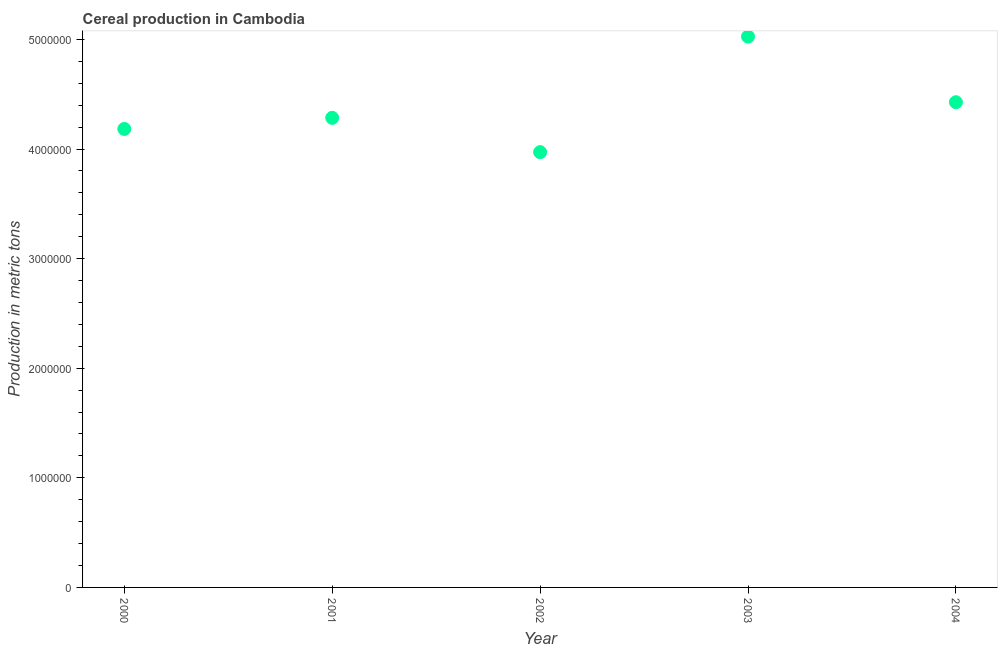What is the cereal production in 2001?
Keep it short and to the point. 4.28e+06. Across all years, what is the maximum cereal production?
Offer a terse response. 5.03e+06. Across all years, what is the minimum cereal production?
Keep it short and to the point. 3.97e+06. In which year was the cereal production maximum?
Offer a terse response. 2003. What is the sum of the cereal production?
Your answer should be compact. 2.19e+07. What is the difference between the cereal production in 2000 and 2002?
Ensure brevity in your answer.  2.12e+05. What is the average cereal production per year?
Provide a short and direct response. 4.38e+06. What is the median cereal production?
Provide a succinct answer. 4.28e+06. In how many years, is the cereal production greater than 1200000 metric tons?
Ensure brevity in your answer.  5. Do a majority of the years between 2001 and 2002 (inclusive) have cereal production greater than 2400000 metric tons?
Your response must be concise. Yes. What is the ratio of the cereal production in 2002 to that in 2003?
Your response must be concise. 0.79. What is the difference between the highest and the second highest cereal production?
Your answer should be very brief. 5.99e+05. What is the difference between the highest and the lowest cereal production?
Ensure brevity in your answer.  1.05e+06. Does the cereal production monotonically increase over the years?
Ensure brevity in your answer.  No. How many dotlines are there?
Your answer should be compact. 1. Does the graph contain grids?
Keep it short and to the point. No. What is the title of the graph?
Offer a terse response. Cereal production in Cambodia. What is the label or title of the X-axis?
Your answer should be compact. Year. What is the label or title of the Y-axis?
Offer a terse response. Production in metric tons. What is the Production in metric tons in 2000?
Your response must be concise. 4.18e+06. What is the Production in metric tons in 2001?
Make the answer very short. 4.28e+06. What is the Production in metric tons in 2002?
Provide a succinct answer. 3.97e+06. What is the Production in metric tons in 2003?
Provide a succinct answer. 5.03e+06. What is the Production in metric tons in 2004?
Offer a terse response. 4.43e+06. What is the difference between the Production in metric tons in 2000 and 2001?
Your response must be concise. -1.02e+05. What is the difference between the Production in metric tons in 2000 and 2002?
Keep it short and to the point. 2.12e+05. What is the difference between the Production in metric tons in 2000 and 2003?
Ensure brevity in your answer.  -8.42e+05. What is the difference between the Production in metric tons in 2000 and 2004?
Keep it short and to the point. -2.44e+05. What is the difference between the Production in metric tons in 2001 and 2002?
Make the answer very short. 3.13e+05. What is the difference between the Production in metric tons in 2001 and 2003?
Ensure brevity in your answer.  -7.41e+05. What is the difference between the Production in metric tons in 2001 and 2004?
Provide a short and direct response. -1.42e+05. What is the difference between the Production in metric tons in 2002 and 2003?
Offer a terse response. -1.05e+06. What is the difference between the Production in metric tons in 2002 and 2004?
Your answer should be compact. -4.56e+05. What is the difference between the Production in metric tons in 2003 and 2004?
Your response must be concise. 5.99e+05. What is the ratio of the Production in metric tons in 2000 to that in 2002?
Provide a short and direct response. 1.05. What is the ratio of the Production in metric tons in 2000 to that in 2003?
Give a very brief answer. 0.83. What is the ratio of the Production in metric tons in 2000 to that in 2004?
Your response must be concise. 0.94. What is the ratio of the Production in metric tons in 2001 to that in 2002?
Offer a very short reply. 1.08. What is the ratio of the Production in metric tons in 2001 to that in 2003?
Provide a short and direct response. 0.85. What is the ratio of the Production in metric tons in 2001 to that in 2004?
Your answer should be very brief. 0.97. What is the ratio of the Production in metric tons in 2002 to that in 2003?
Provide a succinct answer. 0.79. What is the ratio of the Production in metric tons in 2002 to that in 2004?
Your answer should be very brief. 0.9. What is the ratio of the Production in metric tons in 2003 to that in 2004?
Your answer should be very brief. 1.14. 